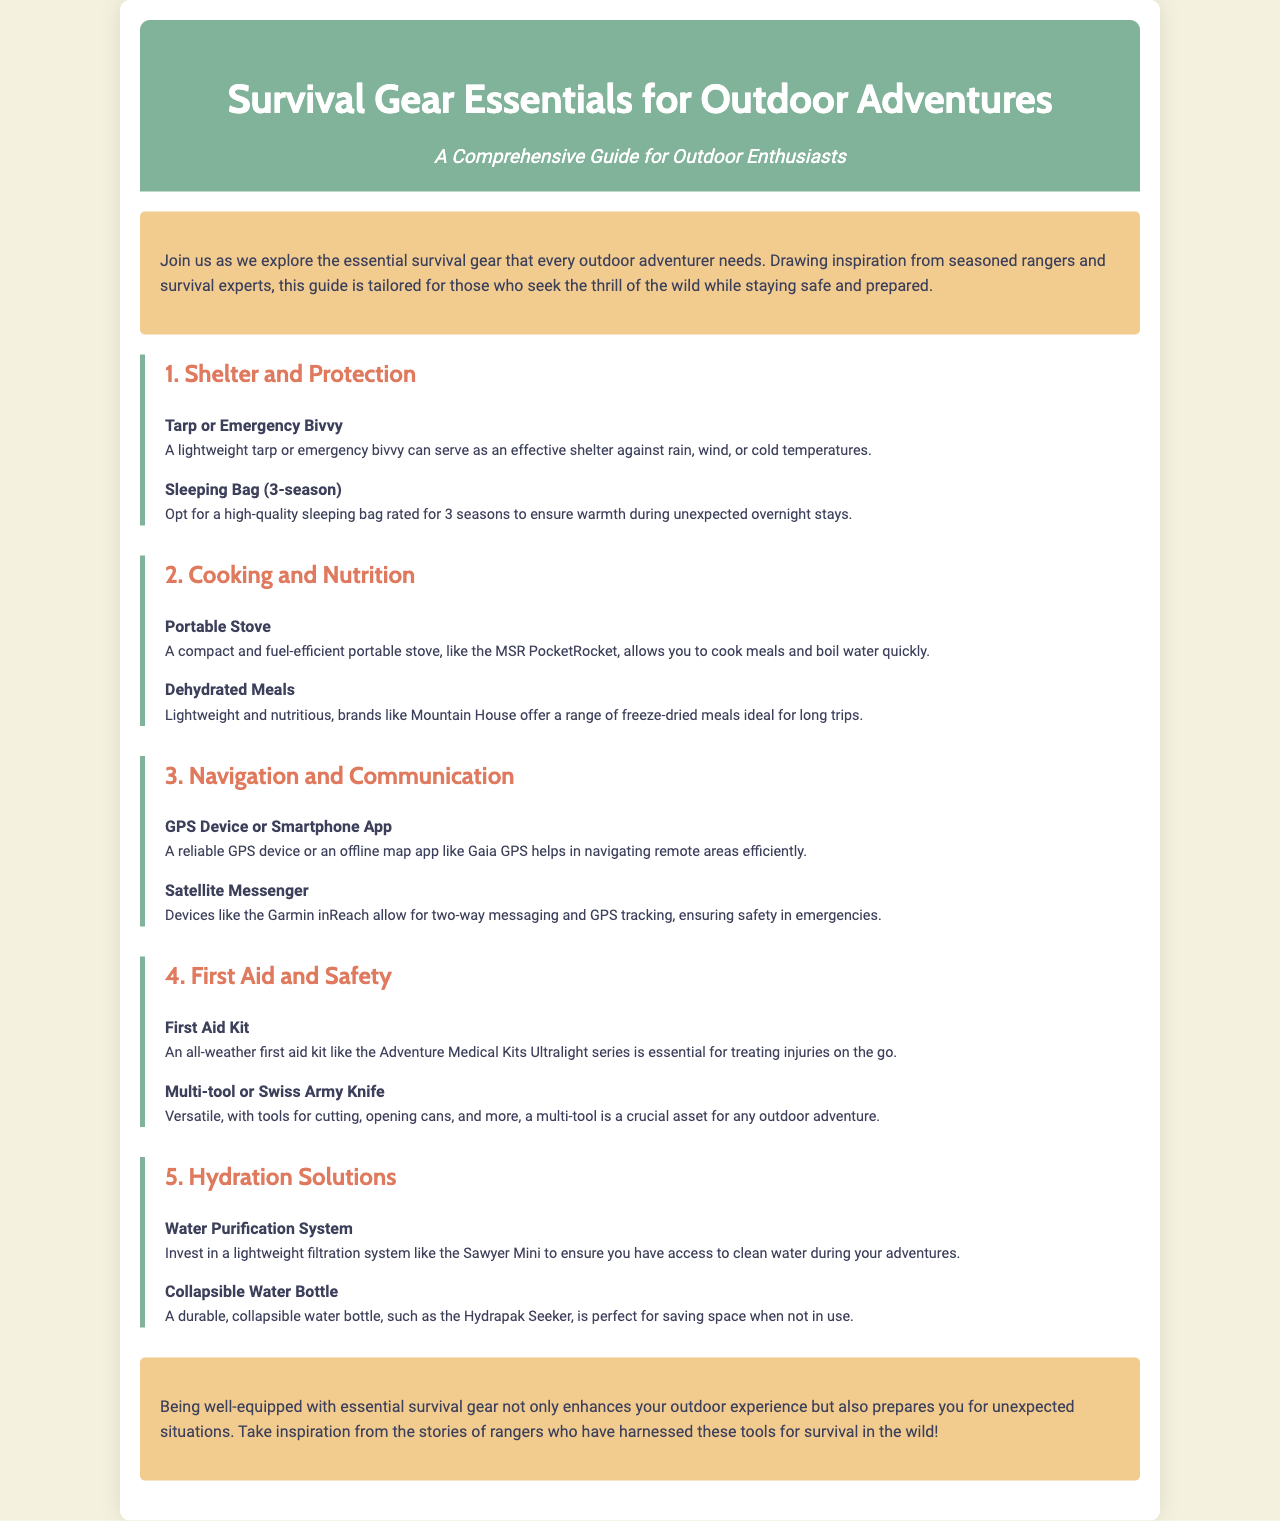What is the title of the brochure? The title is mentioned at the top of the document in a prominent header.
Answer: Survival Gear Essentials for Outdoor Adventures How many sections are there in the brochure? The brochure has multiple sections, each focusing on different aspects of survival gear.
Answer: 5 What is a recommended item for cooking? This item is specified under the "Cooking and Nutrition" section.
Answer: Portable Stove Which device is suggested for navigation? The navigation section lists a device to assist with finding directions in remote areas.
Answer: GPS Device or Smartphone App What kind of first aid kit is mentioned? The document specifies a particular type of first aid kit essential for outdoor adventures.
Answer: all-weather first aid kit What is the purpose of a satellite messenger? The brochure explains the functionality of this device in relation to safety during outdoor adventures.
Answer: two-way messaging and GPS tracking Which hydration solution is lightweight? The document highlights a hydration solution that is easier to carry due to its design.
Answer: Water Purification System What is a key feature of dehydrated meals? The brochure describes a characteristic of these meals that makes them suitable for trips.
Answer: lightweight and nutritious What style is the header of the brochure? The styling details provided indicate how the header is presented visually.
Answer: centered and background-colored 